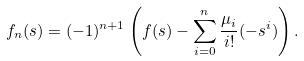<formula> <loc_0><loc_0><loc_500><loc_500>f _ { n } ( s ) = ( - 1 ) ^ { n + 1 } \left ( f ( s ) - \sum _ { i = 0 } ^ { n } \frac { \mu _ { i } } { i ! } ( - s ^ { i } ) \right ) .</formula> 